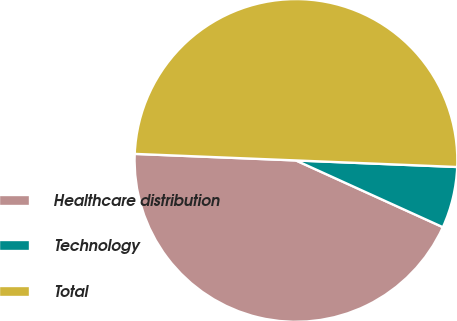Convert chart to OTSL. <chart><loc_0><loc_0><loc_500><loc_500><pie_chart><fcel>Healthcare distribution<fcel>Technology<fcel>Total<nl><fcel>43.86%<fcel>6.14%<fcel>50.0%<nl></chart> 